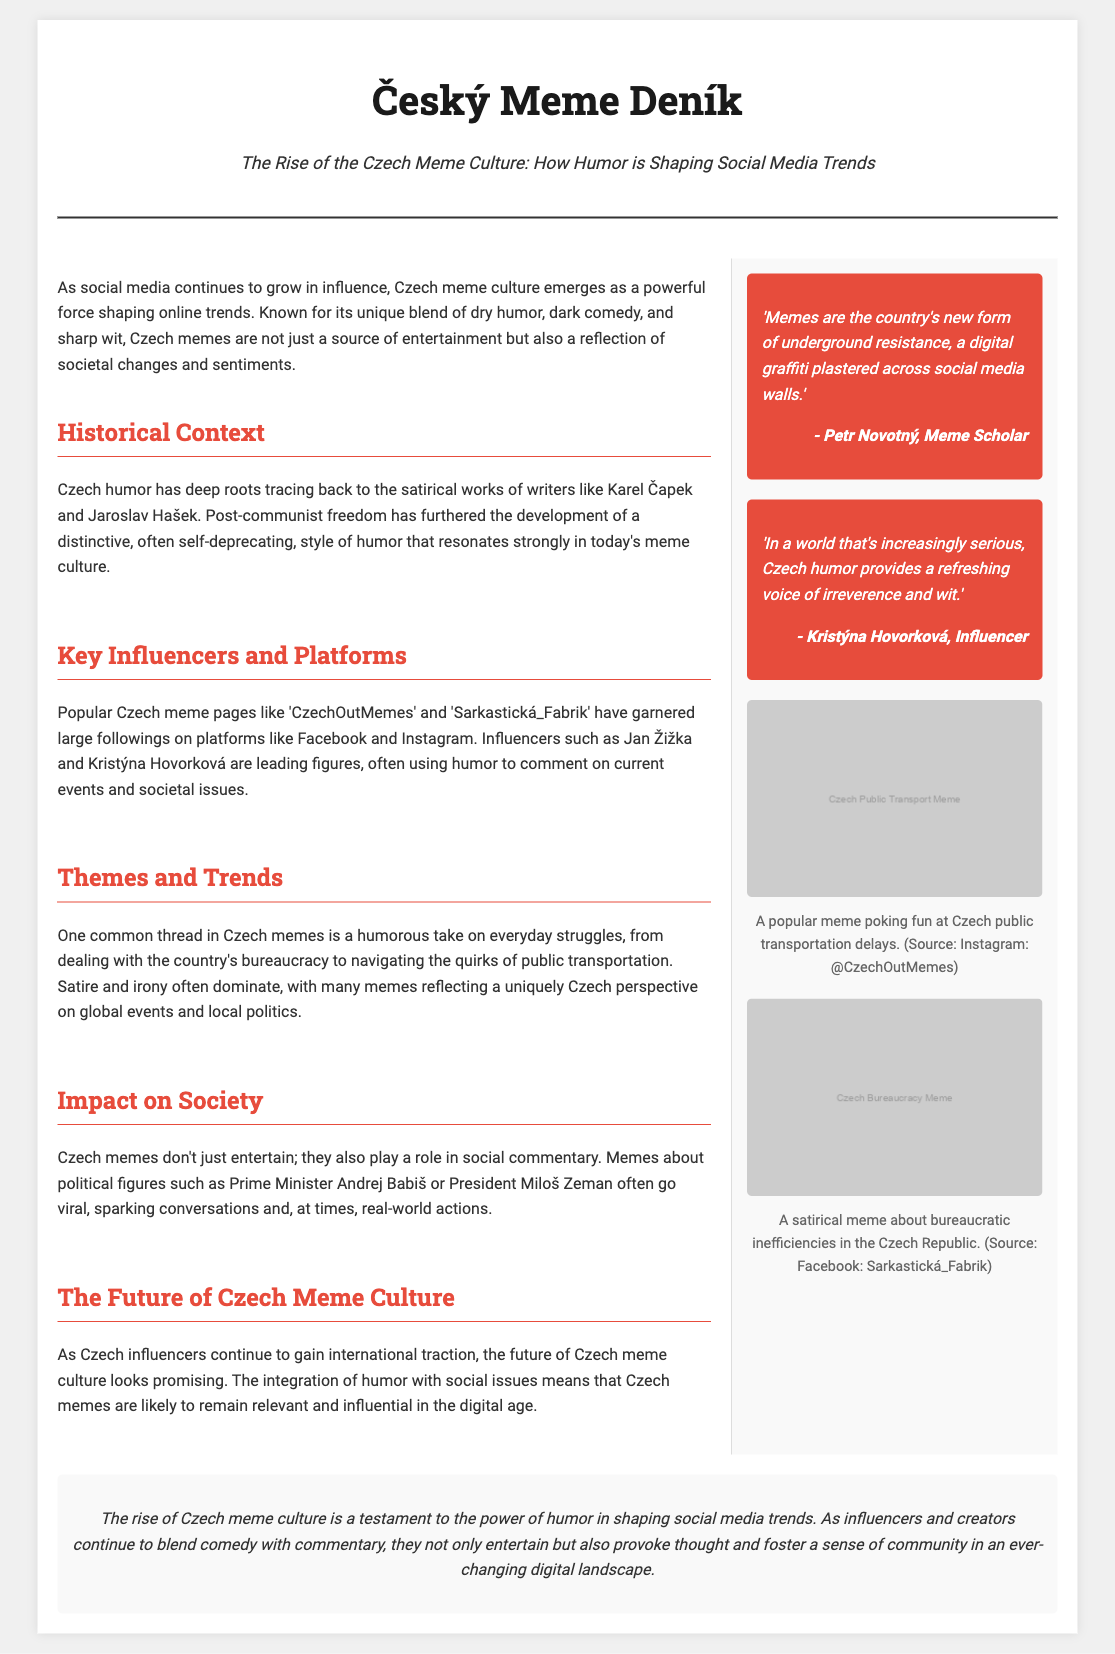what are the roots of Czech humor? The document states that Czech humor has deep roots tracing back to the satirical works of writers like Karel Čapek and Jaroslav Hašek.
Answer: satirical works of Karel Čapek and Jaroslav Hašek which meme pages are mentioned as popular? The document mentions popular Czech meme pages like 'CzechOutMemes' and 'Sarkastická_Fabrik'.
Answer: CzechOutMemes, Sarkastická_Fabrik who is a widely recognized meme scholar quoted in the document? The document quotes Petr Novotný as a meme scholar.
Answer: Petr Novotný what major theme is common in Czech memes? The document highlights that one common thread in Czech memes is a humorous take on everyday struggles.
Answer: humorous take on everyday struggles what is the future outlook of Czech meme culture? The document states that the future of Czech meme culture looks promising with influencers gaining international traction.
Answer: promising how does the document classify the influence of Czech memes? The document explains that Czech memes also play a role in social commentary.
Answer: social commentary which political figures are mentioned in the context of Czech memes? The document mentions Prime Minister Andrej Babiš and President Miloš Zeman.
Answer: Andrej Babiš, Miloš Zeman what type of humor is a hallmark of Czech memes? The document indicates that satire and irony often dominate Czech memes.
Answer: satire and irony what is the name of an influencer mentioned in the document? The document mentions Kristýna Hovorková as an influencer.
Answer: Kristýna Hovorková 